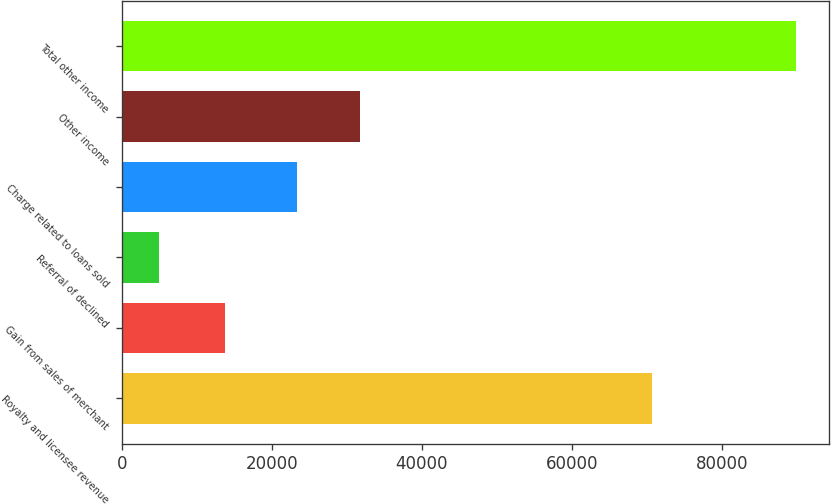Convert chart. <chart><loc_0><loc_0><loc_500><loc_500><bar_chart><fcel>Royalty and licensee revenue<fcel>Gain from sales of merchant<fcel>Referral of declined<fcel>Charge related to loans sold<fcel>Other income<fcel>Total other income<nl><fcel>70645<fcel>13688<fcel>4982<fcel>23307<fcel>31789.6<fcel>89808<nl></chart> 